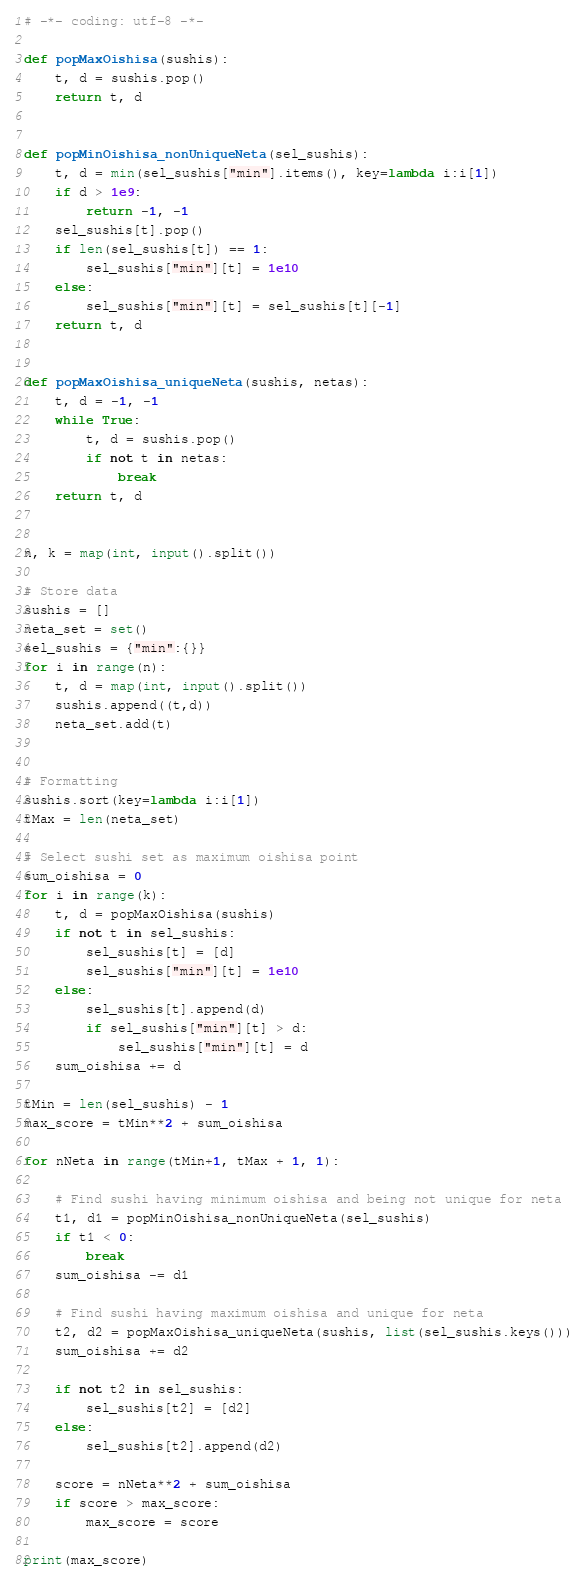Convert code to text. <code><loc_0><loc_0><loc_500><loc_500><_Python_># -*- coding: utf-8 -*-

def popMaxOishisa(sushis):
    t, d = sushis.pop()
    return t, d


def popMinOishisa_nonUniqueNeta(sel_sushis):
    t, d = min(sel_sushis["min"].items(), key=lambda i:i[1])
    if d > 1e9:
        return -1, -1
    sel_sushis[t].pop()
    if len(sel_sushis[t]) == 1:
        sel_sushis["min"][t] = 1e10
    else:
        sel_sushis["min"][t] = sel_sushis[t][-1]
    return t, d


def popMaxOishisa_uniqueNeta(sushis, netas):
    t, d = -1, -1
    while True:
        t, d = sushis.pop()
        if not t in netas:
            break
    return t, d


n, k = map(int, input().split())

# Store data
sushis = []
neta_set = set()
sel_sushis = {"min":{}}
for i in range(n):
    t, d = map(int, input().split())
    sushis.append((t,d))
    neta_set.add(t)


# Formatting
sushis.sort(key=lambda i:i[1])
tMax = len(neta_set)

# Select sushi set as maximum oishisa point
sum_oishisa = 0
for i in range(k):
    t, d = popMaxOishisa(sushis)
    if not t in sel_sushis:
        sel_sushis[t] = [d]
        sel_sushis["min"][t] = 1e10
    else:
        sel_sushis[t].append(d)
        if sel_sushis["min"][t] > d:
            sel_sushis["min"][t] = d
    sum_oishisa += d

tMin = len(sel_sushis) - 1
max_score = tMin**2 + sum_oishisa

for nNeta in range(tMin+1, tMax + 1, 1):

    # Find sushi having minimum oishisa and being not unique for neta
    t1, d1 = popMinOishisa_nonUniqueNeta(sel_sushis)
    if t1 < 0:
        break
    sum_oishisa -= d1

    # Find sushi having maximum oishisa and unique for neta
    t2, d2 = popMaxOishisa_uniqueNeta(sushis, list(sel_sushis.keys()))
    sum_oishisa += d2

    if not t2 in sel_sushis:
        sel_sushis[t2] = [d2]
    else:
        sel_sushis[t2].append(d2)

    score = nNeta**2 + sum_oishisa
    if score > max_score:
        max_score = score

print(max_score)
</code> 